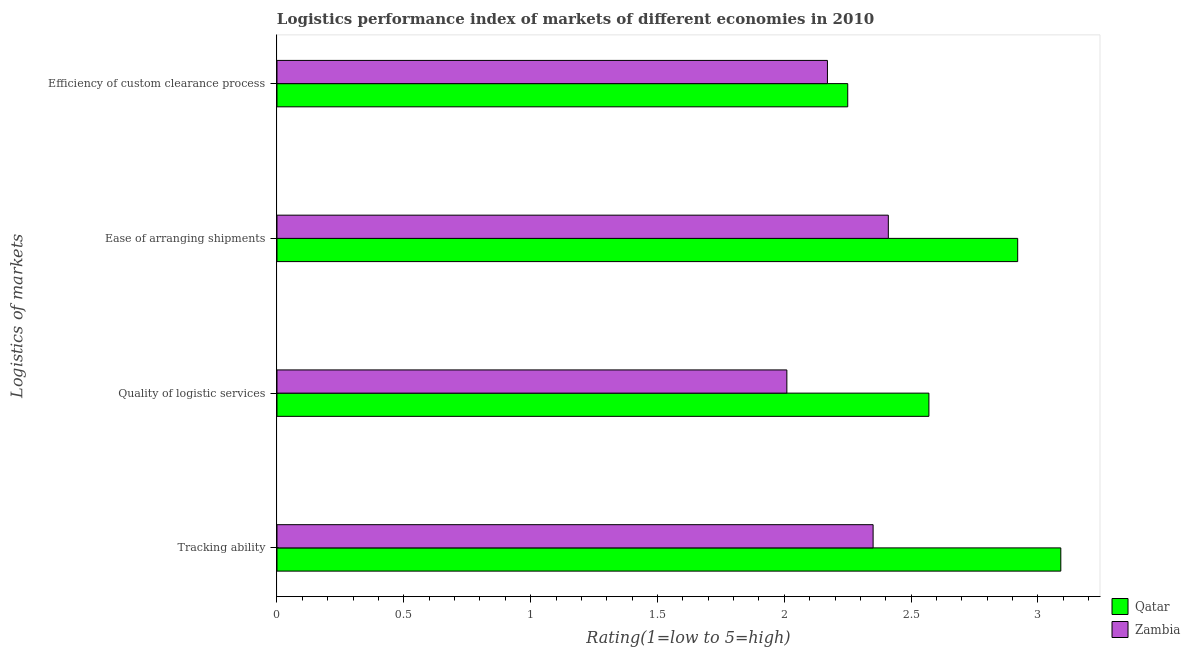How many groups of bars are there?
Keep it short and to the point. 4. How many bars are there on the 2nd tick from the top?
Give a very brief answer. 2. How many bars are there on the 3rd tick from the bottom?
Make the answer very short. 2. What is the label of the 2nd group of bars from the top?
Your response must be concise. Ease of arranging shipments. What is the lpi rating of tracking ability in Zambia?
Offer a terse response. 2.35. Across all countries, what is the maximum lpi rating of tracking ability?
Your answer should be compact. 3.09. Across all countries, what is the minimum lpi rating of efficiency of custom clearance process?
Make the answer very short. 2.17. In which country was the lpi rating of ease of arranging shipments maximum?
Your answer should be very brief. Qatar. In which country was the lpi rating of tracking ability minimum?
Offer a very short reply. Zambia. What is the total lpi rating of efficiency of custom clearance process in the graph?
Ensure brevity in your answer.  4.42. What is the difference between the lpi rating of tracking ability in Qatar and that in Zambia?
Make the answer very short. 0.74. What is the difference between the lpi rating of tracking ability in Zambia and the lpi rating of quality of logistic services in Qatar?
Provide a short and direct response. -0.22. What is the average lpi rating of quality of logistic services per country?
Your answer should be very brief. 2.29. What is the difference between the lpi rating of efficiency of custom clearance process and lpi rating of tracking ability in Qatar?
Keep it short and to the point. -0.84. In how many countries, is the lpi rating of tracking ability greater than 1.1 ?
Make the answer very short. 2. What is the ratio of the lpi rating of ease of arranging shipments in Qatar to that in Zambia?
Keep it short and to the point. 1.21. What is the difference between the highest and the second highest lpi rating of efficiency of custom clearance process?
Provide a short and direct response. 0.08. What is the difference between the highest and the lowest lpi rating of ease of arranging shipments?
Ensure brevity in your answer.  0.51. Is the sum of the lpi rating of tracking ability in Qatar and Zambia greater than the maximum lpi rating of ease of arranging shipments across all countries?
Offer a very short reply. Yes. Is it the case that in every country, the sum of the lpi rating of tracking ability and lpi rating of ease of arranging shipments is greater than the sum of lpi rating of quality of logistic services and lpi rating of efficiency of custom clearance process?
Provide a short and direct response. No. What does the 1st bar from the top in Quality of logistic services represents?
Provide a short and direct response. Zambia. What does the 2nd bar from the bottom in Tracking ability represents?
Keep it short and to the point. Zambia. Is it the case that in every country, the sum of the lpi rating of tracking ability and lpi rating of quality of logistic services is greater than the lpi rating of ease of arranging shipments?
Offer a terse response. Yes. Does the graph contain grids?
Provide a succinct answer. No. Where does the legend appear in the graph?
Give a very brief answer. Bottom right. What is the title of the graph?
Keep it short and to the point. Logistics performance index of markets of different economies in 2010. Does "Trinidad and Tobago" appear as one of the legend labels in the graph?
Give a very brief answer. No. What is the label or title of the X-axis?
Give a very brief answer. Rating(1=low to 5=high). What is the label or title of the Y-axis?
Provide a short and direct response. Logistics of markets. What is the Rating(1=low to 5=high) of Qatar in Tracking ability?
Your answer should be very brief. 3.09. What is the Rating(1=low to 5=high) of Zambia in Tracking ability?
Provide a short and direct response. 2.35. What is the Rating(1=low to 5=high) in Qatar in Quality of logistic services?
Ensure brevity in your answer.  2.57. What is the Rating(1=low to 5=high) in Zambia in Quality of logistic services?
Offer a very short reply. 2.01. What is the Rating(1=low to 5=high) of Qatar in Ease of arranging shipments?
Your response must be concise. 2.92. What is the Rating(1=low to 5=high) in Zambia in Ease of arranging shipments?
Give a very brief answer. 2.41. What is the Rating(1=low to 5=high) in Qatar in Efficiency of custom clearance process?
Your response must be concise. 2.25. What is the Rating(1=low to 5=high) in Zambia in Efficiency of custom clearance process?
Provide a succinct answer. 2.17. Across all Logistics of markets, what is the maximum Rating(1=low to 5=high) of Qatar?
Your answer should be very brief. 3.09. Across all Logistics of markets, what is the maximum Rating(1=low to 5=high) in Zambia?
Offer a terse response. 2.41. Across all Logistics of markets, what is the minimum Rating(1=low to 5=high) in Qatar?
Provide a short and direct response. 2.25. Across all Logistics of markets, what is the minimum Rating(1=low to 5=high) of Zambia?
Offer a very short reply. 2.01. What is the total Rating(1=low to 5=high) of Qatar in the graph?
Offer a terse response. 10.83. What is the total Rating(1=low to 5=high) of Zambia in the graph?
Provide a succinct answer. 8.94. What is the difference between the Rating(1=low to 5=high) of Qatar in Tracking ability and that in Quality of logistic services?
Your answer should be compact. 0.52. What is the difference between the Rating(1=low to 5=high) in Zambia in Tracking ability and that in Quality of logistic services?
Offer a terse response. 0.34. What is the difference between the Rating(1=low to 5=high) in Qatar in Tracking ability and that in Ease of arranging shipments?
Your answer should be compact. 0.17. What is the difference between the Rating(1=low to 5=high) in Zambia in Tracking ability and that in Ease of arranging shipments?
Keep it short and to the point. -0.06. What is the difference between the Rating(1=low to 5=high) in Qatar in Tracking ability and that in Efficiency of custom clearance process?
Your answer should be compact. 0.84. What is the difference between the Rating(1=low to 5=high) in Zambia in Tracking ability and that in Efficiency of custom clearance process?
Offer a terse response. 0.18. What is the difference between the Rating(1=low to 5=high) of Qatar in Quality of logistic services and that in Ease of arranging shipments?
Give a very brief answer. -0.35. What is the difference between the Rating(1=low to 5=high) of Qatar in Quality of logistic services and that in Efficiency of custom clearance process?
Your answer should be compact. 0.32. What is the difference between the Rating(1=low to 5=high) in Zambia in Quality of logistic services and that in Efficiency of custom clearance process?
Offer a terse response. -0.16. What is the difference between the Rating(1=low to 5=high) in Qatar in Ease of arranging shipments and that in Efficiency of custom clearance process?
Your answer should be compact. 0.67. What is the difference between the Rating(1=low to 5=high) in Zambia in Ease of arranging shipments and that in Efficiency of custom clearance process?
Your response must be concise. 0.24. What is the difference between the Rating(1=low to 5=high) in Qatar in Tracking ability and the Rating(1=low to 5=high) in Zambia in Ease of arranging shipments?
Your answer should be very brief. 0.68. What is the difference between the Rating(1=low to 5=high) in Qatar in Tracking ability and the Rating(1=low to 5=high) in Zambia in Efficiency of custom clearance process?
Make the answer very short. 0.92. What is the difference between the Rating(1=low to 5=high) in Qatar in Quality of logistic services and the Rating(1=low to 5=high) in Zambia in Ease of arranging shipments?
Ensure brevity in your answer.  0.16. What is the difference between the Rating(1=low to 5=high) in Qatar in Quality of logistic services and the Rating(1=low to 5=high) in Zambia in Efficiency of custom clearance process?
Keep it short and to the point. 0.4. What is the average Rating(1=low to 5=high) in Qatar per Logistics of markets?
Keep it short and to the point. 2.71. What is the average Rating(1=low to 5=high) in Zambia per Logistics of markets?
Offer a very short reply. 2.23. What is the difference between the Rating(1=low to 5=high) in Qatar and Rating(1=low to 5=high) in Zambia in Tracking ability?
Your answer should be very brief. 0.74. What is the difference between the Rating(1=low to 5=high) in Qatar and Rating(1=low to 5=high) in Zambia in Quality of logistic services?
Offer a very short reply. 0.56. What is the difference between the Rating(1=low to 5=high) in Qatar and Rating(1=low to 5=high) in Zambia in Ease of arranging shipments?
Your answer should be very brief. 0.51. What is the ratio of the Rating(1=low to 5=high) in Qatar in Tracking ability to that in Quality of logistic services?
Give a very brief answer. 1.2. What is the ratio of the Rating(1=low to 5=high) in Zambia in Tracking ability to that in Quality of logistic services?
Provide a succinct answer. 1.17. What is the ratio of the Rating(1=low to 5=high) of Qatar in Tracking ability to that in Ease of arranging shipments?
Ensure brevity in your answer.  1.06. What is the ratio of the Rating(1=low to 5=high) in Zambia in Tracking ability to that in Ease of arranging shipments?
Your response must be concise. 0.98. What is the ratio of the Rating(1=low to 5=high) of Qatar in Tracking ability to that in Efficiency of custom clearance process?
Offer a very short reply. 1.37. What is the ratio of the Rating(1=low to 5=high) in Zambia in Tracking ability to that in Efficiency of custom clearance process?
Offer a terse response. 1.08. What is the ratio of the Rating(1=low to 5=high) of Qatar in Quality of logistic services to that in Ease of arranging shipments?
Provide a short and direct response. 0.88. What is the ratio of the Rating(1=low to 5=high) of Zambia in Quality of logistic services to that in Ease of arranging shipments?
Your answer should be very brief. 0.83. What is the ratio of the Rating(1=low to 5=high) in Qatar in Quality of logistic services to that in Efficiency of custom clearance process?
Keep it short and to the point. 1.14. What is the ratio of the Rating(1=low to 5=high) in Zambia in Quality of logistic services to that in Efficiency of custom clearance process?
Ensure brevity in your answer.  0.93. What is the ratio of the Rating(1=low to 5=high) in Qatar in Ease of arranging shipments to that in Efficiency of custom clearance process?
Keep it short and to the point. 1.3. What is the ratio of the Rating(1=low to 5=high) in Zambia in Ease of arranging shipments to that in Efficiency of custom clearance process?
Your answer should be very brief. 1.11. What is the difference between the highest and the second highest Rating(1=low to 5=high) of Qatar?
Make the answer very short. 0.17. What is the difference between the highest and the second highest Rating(1=low to 5=high) of Zambia?
Provide a short and direct response. 0.06. What is the difference between the highest and the lowest Rating(1=low to 5=high) of Qatar?
Ensure brevity in your answer.  0.84. 